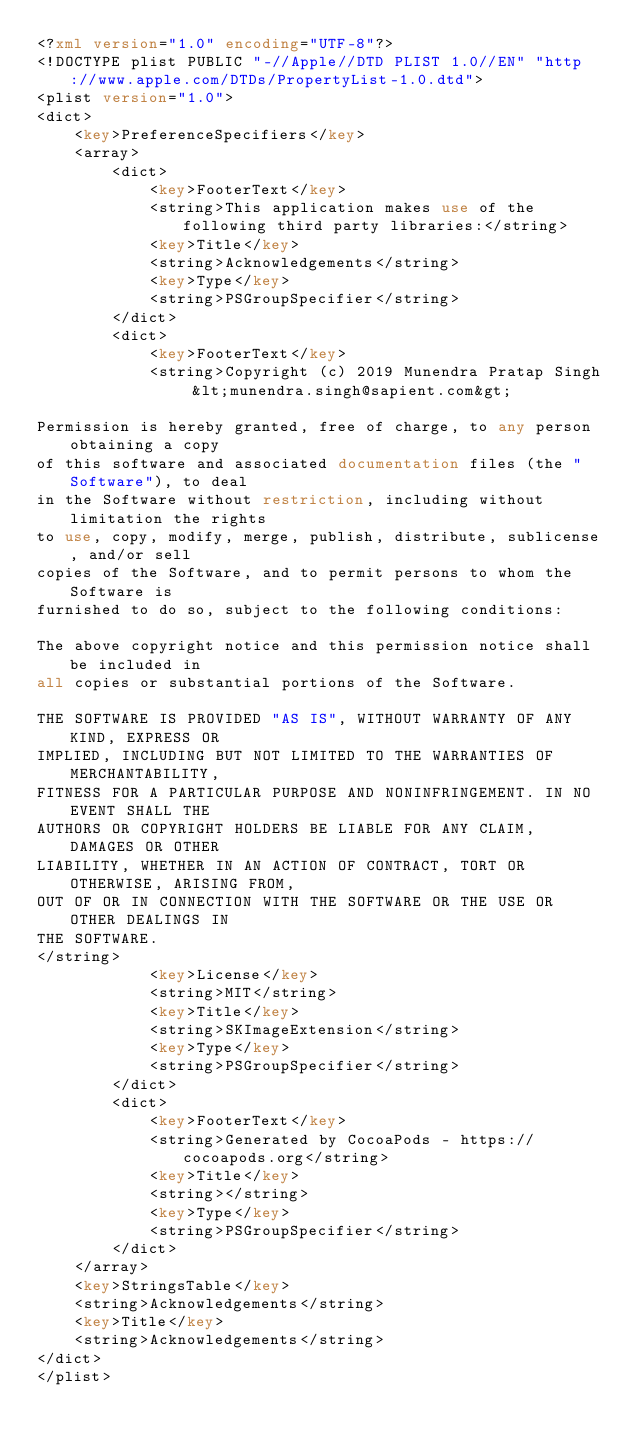Convert code to text. <code><loc_0><loc_0><loc_500><loc_500><_XML_><?xml version="1.0" encoding="UTF-8"?>
<!DOCTYPE plist PUBLIC "-//Apple//DTD PLIST 1.0//EN" "http://www.apple.com/DTDs/PropertyList-1.0.dtd">
<plist version="1.0">
<dict>
	<key>PreferenceSpecifiers</key>
	<array>
		<dict>
			<key>FooterText</key>
			<string>This application makes use of the following third party libraries:</string>
			<key>Title</key>
			<string>Acknowledgements</string>
			<key>Type</key>
			<string>PSGroupSpecifier</string>
		</dict>
		<dict>
			<key>FooterText</key>
			<string>Copyright (c) 2019 Munendra Pratap Singh &lt;munendra.singh@sapient.com&gt;

Permission is hereby granted, free of charge, to any person obtaining a copy
of this software and associated documentation files (the "Software"), to deal
in the Software without restriction, including without limitation the rights
to use, copy, modify, merge, publish, distribute, sublicense, and/or sell
copies of the Software, and to permit persons to whom the Software is
furnished to do so, subject to the following conditions:

The above copyright notice and this permission notice shall be included in
all copies or substantial portions of the Software.

THE SOFTWARE IS PROVIDED "AS IS", WITHOUT WARRANTY OF ANY KIND, EXPRESS OR
IMPLIED, INCLUDING BUT NOT LIMITED TO THE WARRANTIES OF MERCHANTABILITY,
FITNESS FOR A PARTICULAR PURPOSE AND NONINFRINGEMENT. IN NO EVENT SHALL THE
AUTHORS OR COPYRIGHT HOLDERS BE LIABLE FOR ANY CLAIM, DAMAGES OR OTHER
LIABILITY, WHETHER IN AN ACTION OF CONTRACT, TORT OR OTHERWISE, ARISING FROM,
OUT OF OR IN CONNECTION WITH THE SOFTWARE OR THE USE OR OTHER DEALINGS IN
THE SOFTWARE.
</string>
			<key>License</key>
			<string>MIT</string>
			<key>Title</key>
			<string>SKImageExtension</string>
			<key>Type</key>
			<string>PSGroupSpecifier</string>
		</dict>
		<dict>
			<key>FooterText</key>
			<string>Generated by CocoaPods - https://cocoapods.org</string>
			<key>Title</key>
			<string></string>
			<key>Type</key>
			<string>PSGroupSpecifier</string>
		</dict>
	</array>
	<key>StringsTable</key>
	<string>Acknowledgements</string>
	<key>Title</key>
	<string>Acknowledgements</string>
</dict>
</plist>
</code> 